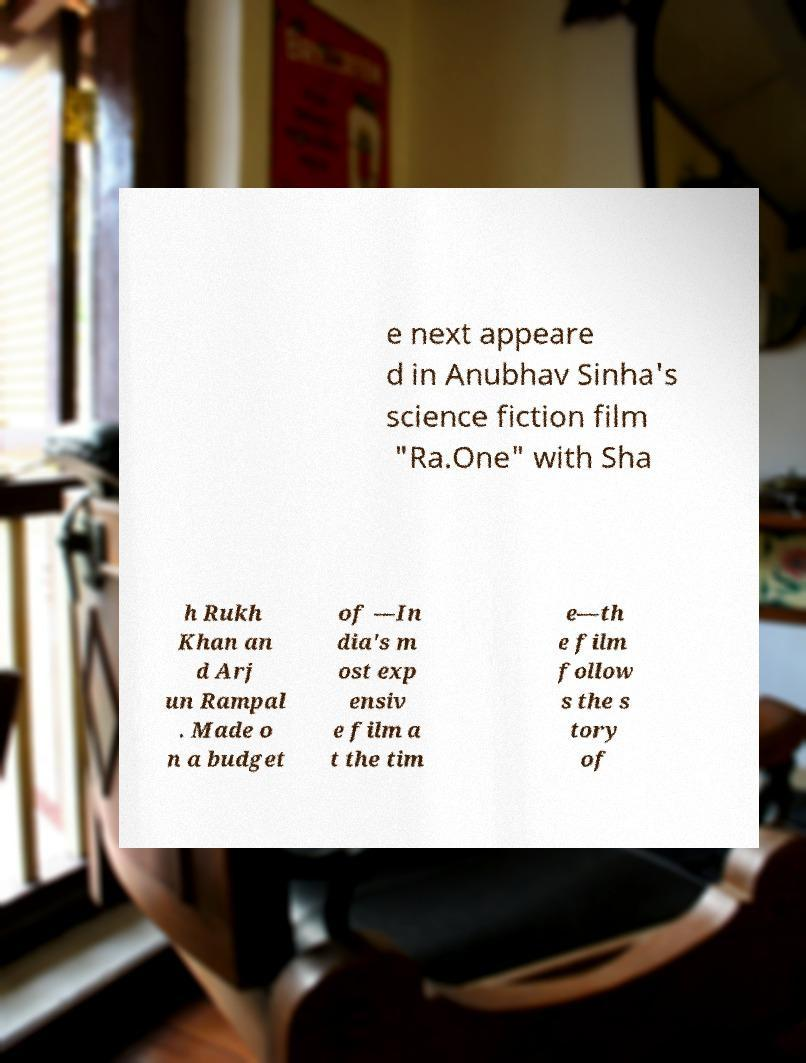Please read and relay the text visible in this image. What does it say? e next appeare d in Anubhav Sinha's science fiction film "Ra.One" with Sha h Rukh Khan an d Arj un Rampal . Made o n a budget of —In dia's m ost exp ensiv e film a t the tim e—th e film follow s the s tory of 